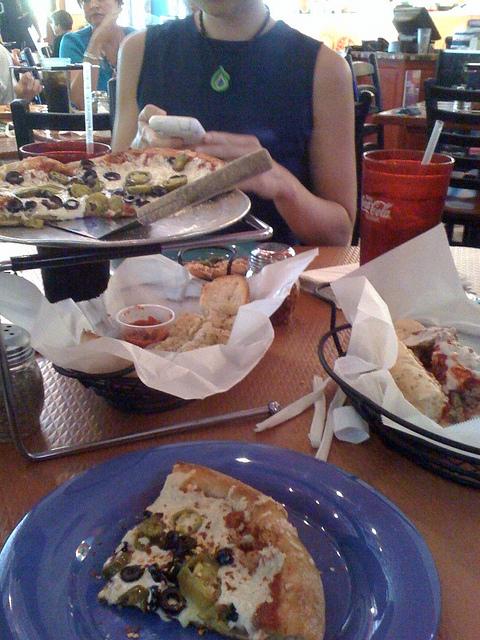Can you describe the atmosphere or possible location this meal might be in? The setting suggests a casual dining restaurant, possibly a pizzeria or family-style Italian eatery given the presence of the pizza and bread items. The establishment exudes a relaxed and informal ambiance, with additional patrons visible in the background, suggesting it's a popular spot for enjoying a meal. 